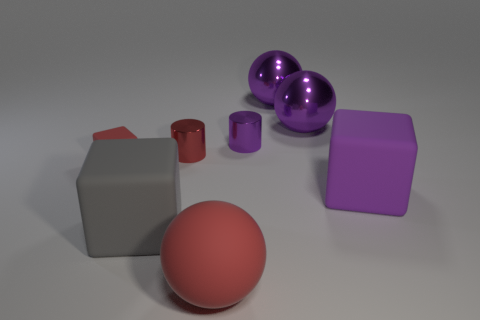Subtract all purple balls. How many were subtracted if there are1purple balls left? 1 Subtract all shiny spheres. How many spheres are left? 1 Subtract all red spheres. How many spheres are left? 2 Subtract 3 blocks. How many blocks are left? 0 Add 1 big brown cubes. How many objects exist? 9 Subtract all balls. How many objects are left? 5 Subtract 0 brown cylinders. How many objects are left? 8 Subtract all gray balls. Subtract all brown cubes. How many balls are left? 3 Subtract all gray balls. How many yellow cylinders are left? 0 Subtract all tiny purple matte spheres. Subtract all red rubber spheres. How many objects are left? 7 